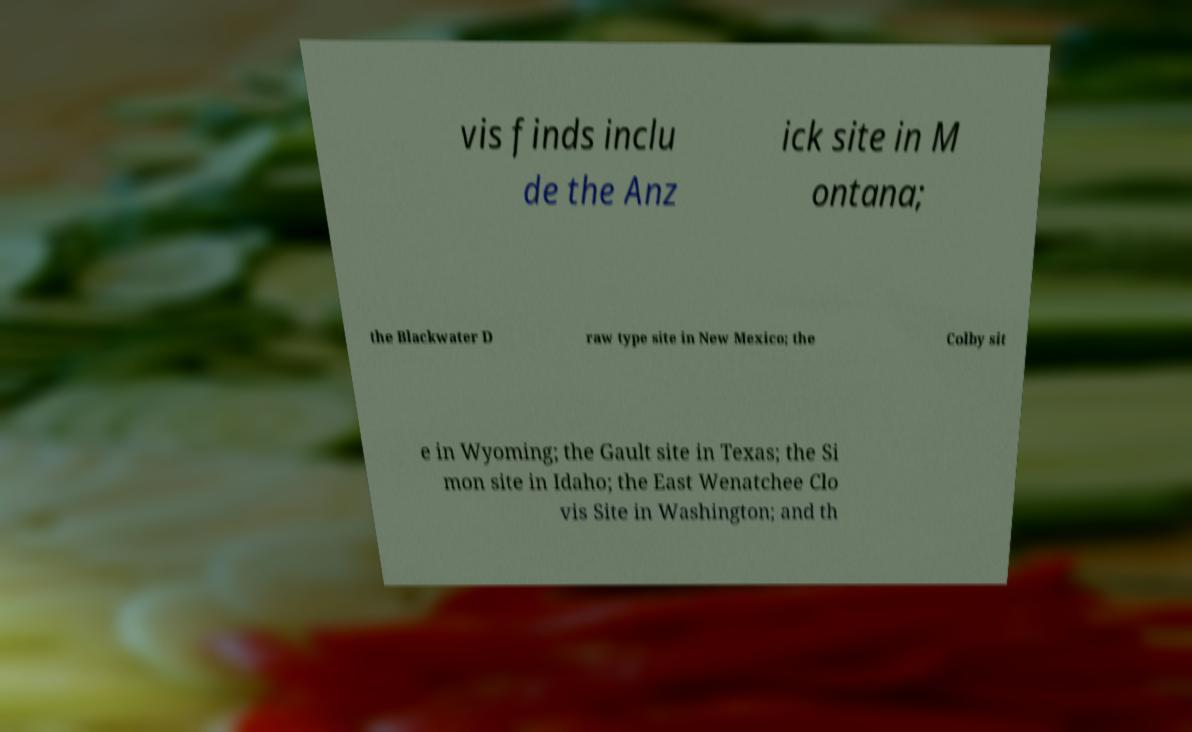For documentation purposes, I need the text within this image transcribed. Could you provide that? vis finds inclu de the Anz ick site in M ontana; the Blackwater D raw type site in New Mexico; the Colby sit e in Wyoming; the Gault site in Texas; the Si mon site in Idaho; the East Wenatchee Clo vis Site in Washington; and th 